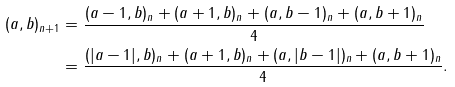Convert formula to latex. <formula><loc_0><loc_0><loc_500><loc_500>( a , b ) _ { n + 1 } & = \frac { ( a - 1 , b ) _ { n } + ( a + 1 , b ) _ { n } + ( a , b - 1 ) _ { n } + ( a , b + 1 ) _ { n } } { 4 } \\ & = \frac { ( | a - 1 | , b ) _ { n } + ( a + 1 , b ) _ { n } + ( a , | b - 1 | ) _ { n } + ( a , b + 1 ) _ { n } } { 4 } .</formula> 